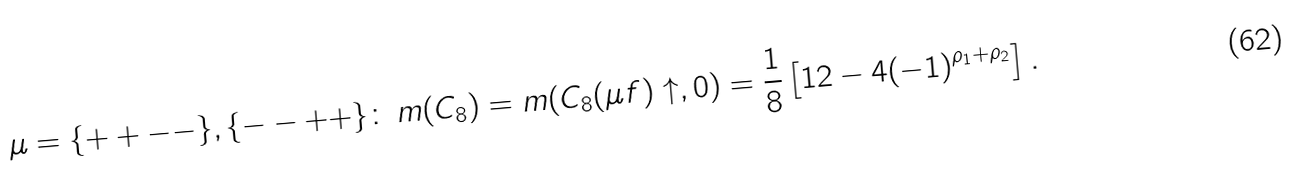<formula> <loc_0><loc_0><loc_500><loc_500>\mu = \{ + + - - \} , \{ - - + + \} \colon \, m ( C _ { 8 } ) = m ( C _ { 8 } ( \mu f ) \uparrow , 0 ) = \frac { 1 } { 8 } \left [ 1 2 - 4 ( - 1 ) ^ { \rho _ { 1 } + \rho _ { 2 } } \right ] .</formula> 